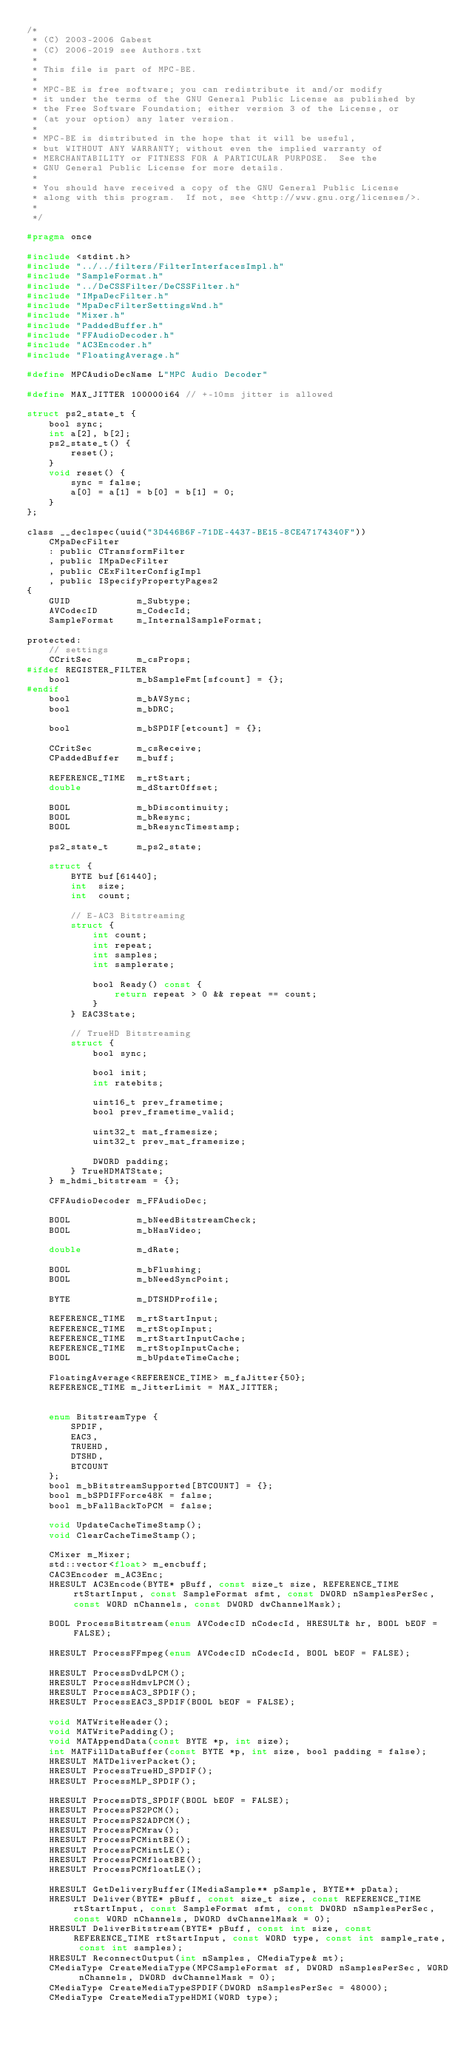Convert code to text. <code><loc_0><loc_0><loc_500><loc_500><_C_>/*
 * (C) 2003-2006 Gabest
 * (C) 2006-2019 see Authors.txt
 *
 * This file is part of MPC-BE.
 *
 * MPC-BE is free software; you can redistribute it and/or modify
 * it under the terms of the GNU General Public License as published by
 * the Free Software Foundation; either version 3 of the License, or
 * (at your option) any later version.
 *
 * MPC-BE is distributed in the hope that it will be useful,
 * but WITHOUT ANY WARRANTY; without even the implied warranty of
 * MERCHANTABILITY or FITNESS FOR A PARTICULAR PURPOSE.  See the
 * GNU General Public License for more details.
 *
 * You should have received a copy of the GNU General Public License
 * along with this program.  If not, see <http://www.gnu.org/licenses/>.
 *
 */

#pragma once

#include <stdint.h>
#include "../../filters/FilterInterfacesImpl.h"
#include "SampleFormat.h"
#include "../DeCSSFilter/DeCSSFilter.h"
#include "IMpaDecFilter.h"
#include "MpaDecFilterSettingsWnd.h"
#include "Mixer.h"
#include "PaddedBuffer.h"
#include "FFAudioDecoder.h"
#include "AC3Encoder.h"
#include "FloatingAverage.h"

#define MPCAudioDecName L"MPC Audio Decoder"

#define MAX_JITTER 100000i64 // +-10ms jitter is allowed

struct ps2_state_t {
	bool sync;
	int a[2], b[2];
	ps2_state_t() {
		reset();
	}
	void reset() {
		sync = false;
		a[0] = a[1] = b[0] = b[1] = 0;
	}
};

class __declspec(uuid("3D446B6F-71DE-4437-BE15-8CE47174340F"))
	CMpaDecFilter
	: public CTransformFilter
	, public IMpaDecFilter
	, public CExFilterConfigImpl
	, public ISpecifyPropertyPages2
{
	GUID            m_Subtype;
	AVCodecID       m_CodecId;
	SampleFormat    m_InternalSampleFormat;

protected:
	// settings
	CCritSec        m_csProps;
#ifdef REGISTER_FILTER
	bool            m_bSampleFmt[sfcount] = {};
#endif
	bool            m_bAVSync;
	bool            m_bDRC;

	bool            m_bSPDIF[etcount] = {};

	CCritSec        m_csReceive;
	CPaddedBuffer   m_buff;

	REFERENCE_TIME  m_rtStart;
	double          m_dStartOffset;

	BOOL            m_bDiscontinuity;
	BOOL            m_bResync;
	BOOL            m_bResyncTimestamp;

	ps2_state_t     m_ps2_state;

	struct {
		BYTE buf[61440];
		int  size;
		int  count;

		// E-AC3 Bitstreaming
		struct {
			int count;
			int repeat;
			int samples;
			int samplerate;

			bool Ready() const {
				return repeat > 0 && repeat == count;
			}
		} EAC3State;

		// TrueHD Bitstreaming
		struct {
			bool sync;

			bool init;
			int ratebits;

			uint16_t prev_frametime;
			bool prev_frametime_valid;

			uint32_t mat_framesize;
			uint32_t prev_mat_framesize;

			DWORD padding;
		} TrueHDMATState;
	} m_hdmi_bitstream = {};

	CFFAudioDecoder m_FFAudioDec;

	BOOL            m_bNeedBitstreamCheck;
	BOOL            m_bHasVideo;

	double          m_dRate;

	BOOL            m_bFlushing;
	BOOL            m_bNeedSyncPoint;

	BYTE            m_DTSHDProfile;

	REFERENCE_TIME  m_rtStartInput;
	REFERENCE_TIME  m_rtStopInput;
	REFERENCE_TIME  m_rtStartInputCache;
	REFERENCE_TIME  m_rtStopInputCache;
	BOOL            m_bUpdateTimeCache;

	FloatingAverage<REFERENCE_TIME> m_faJitter{50};
	REFERENCE_TIME m_JitterLimit = MAX_JITTER;


	enum BitstreamType {
		SPDIF,
		EAC3,
		TRUEHD,
		DTSHD,
		BTCOUNT
	};
	bool m_bBitstreamSupported[BTCOUNT] = {};
	bool m_bSPDIFForce48K = false;
	bool m_bFallBackToPCM = false;

	void UpdateCacheTimeStamp();
	void ClearCacheTimeStamp();

	CMixer m_Mixer;
	std::vector<float> m_encbuff;
	CAC3Encoder m_AC3Enc;
	HRESULT AC3Encode(BYTE* pBuff, const size_t size, REFERENCE_TIME rtStartInput, const SampleFormat sfmt, const DWORD nSamplesPerSec, const WORD nChannels, const DWORD dwChannelMask);

	BOOL ProcessBitstream(enum AVCodecID nCodecId, HRESULT& hr, BOOL bEOF = FALSE);

	HRESULT ProcessFFmpeg(enum AVCodecID nCodecId, BOOL bEOF = FALSE);

	HRESULT ProcessDvdLPCM();
	HRESULT ProcessHdmvLPCM();
	HRESULT ProcessAC3_SPDIF();
	HRESULT ProcessEAC3_SPDIF(BOOL bEOF = FALSE);

	void MATWriteHeader();
	void MATWritePadding();
	void MATAppendData(const BYTE *p, int size);
	int MATFillDataBuffer(const BYTE *p, int size, bool padding = false);
	HRESULT MATDeliverPacket();
	HRESULT ProcessTrueHD_SPDIF();
	HRESULT ProcessMLP_SPDIF();

	HRESULT ProcessDTS_SPDIF(BOOL bEOF = FALSE);
	HRESULT ProcessPS2PCM();
	HRESULT ProcessPS2ADPCM();
	HRESULT ProcessPCMraw();
	HRESULT ProcessPCMintBE();
	HRESULT ProcessPCMintLE();
	HRESULT ProcessPCMfloatBE();
	HRESULT ProcessPCMfloatLE();

	HRESULT GetDeliveryBuffer(IMediaSample** pSample, BYTE** pData);
	HRESULT Deliver(BYTE* pBuff, const size_t size, const REFERENCE_TIME rtStartInput, const SampleFormat sfmt, const DWORD nSamplesPerSec, const WORD nChannels, DWORD dwChannelMask = 0);
	HRESULT DeliverBitstream(BYTE* pBuff, const int size, const REFERENCE_TIME rtStartInput, const WORD type, const int sample_rate, const int samples);
	HRESULT ReconnectOutput(int nSamples, CMediaType& mt);
	CMediaType CreateMediaType(MPCSampleFormat sf, DWORD nSamplesPerSec, WORD nChannels, DWORD dwChannelMask = 0);
	CMediaType CreateMediaTypeSPDIF(DWORD nSamplesPerSec = 48000);
	CMediaType CreateMediaTypeHDMI(WORD type);
</code> 